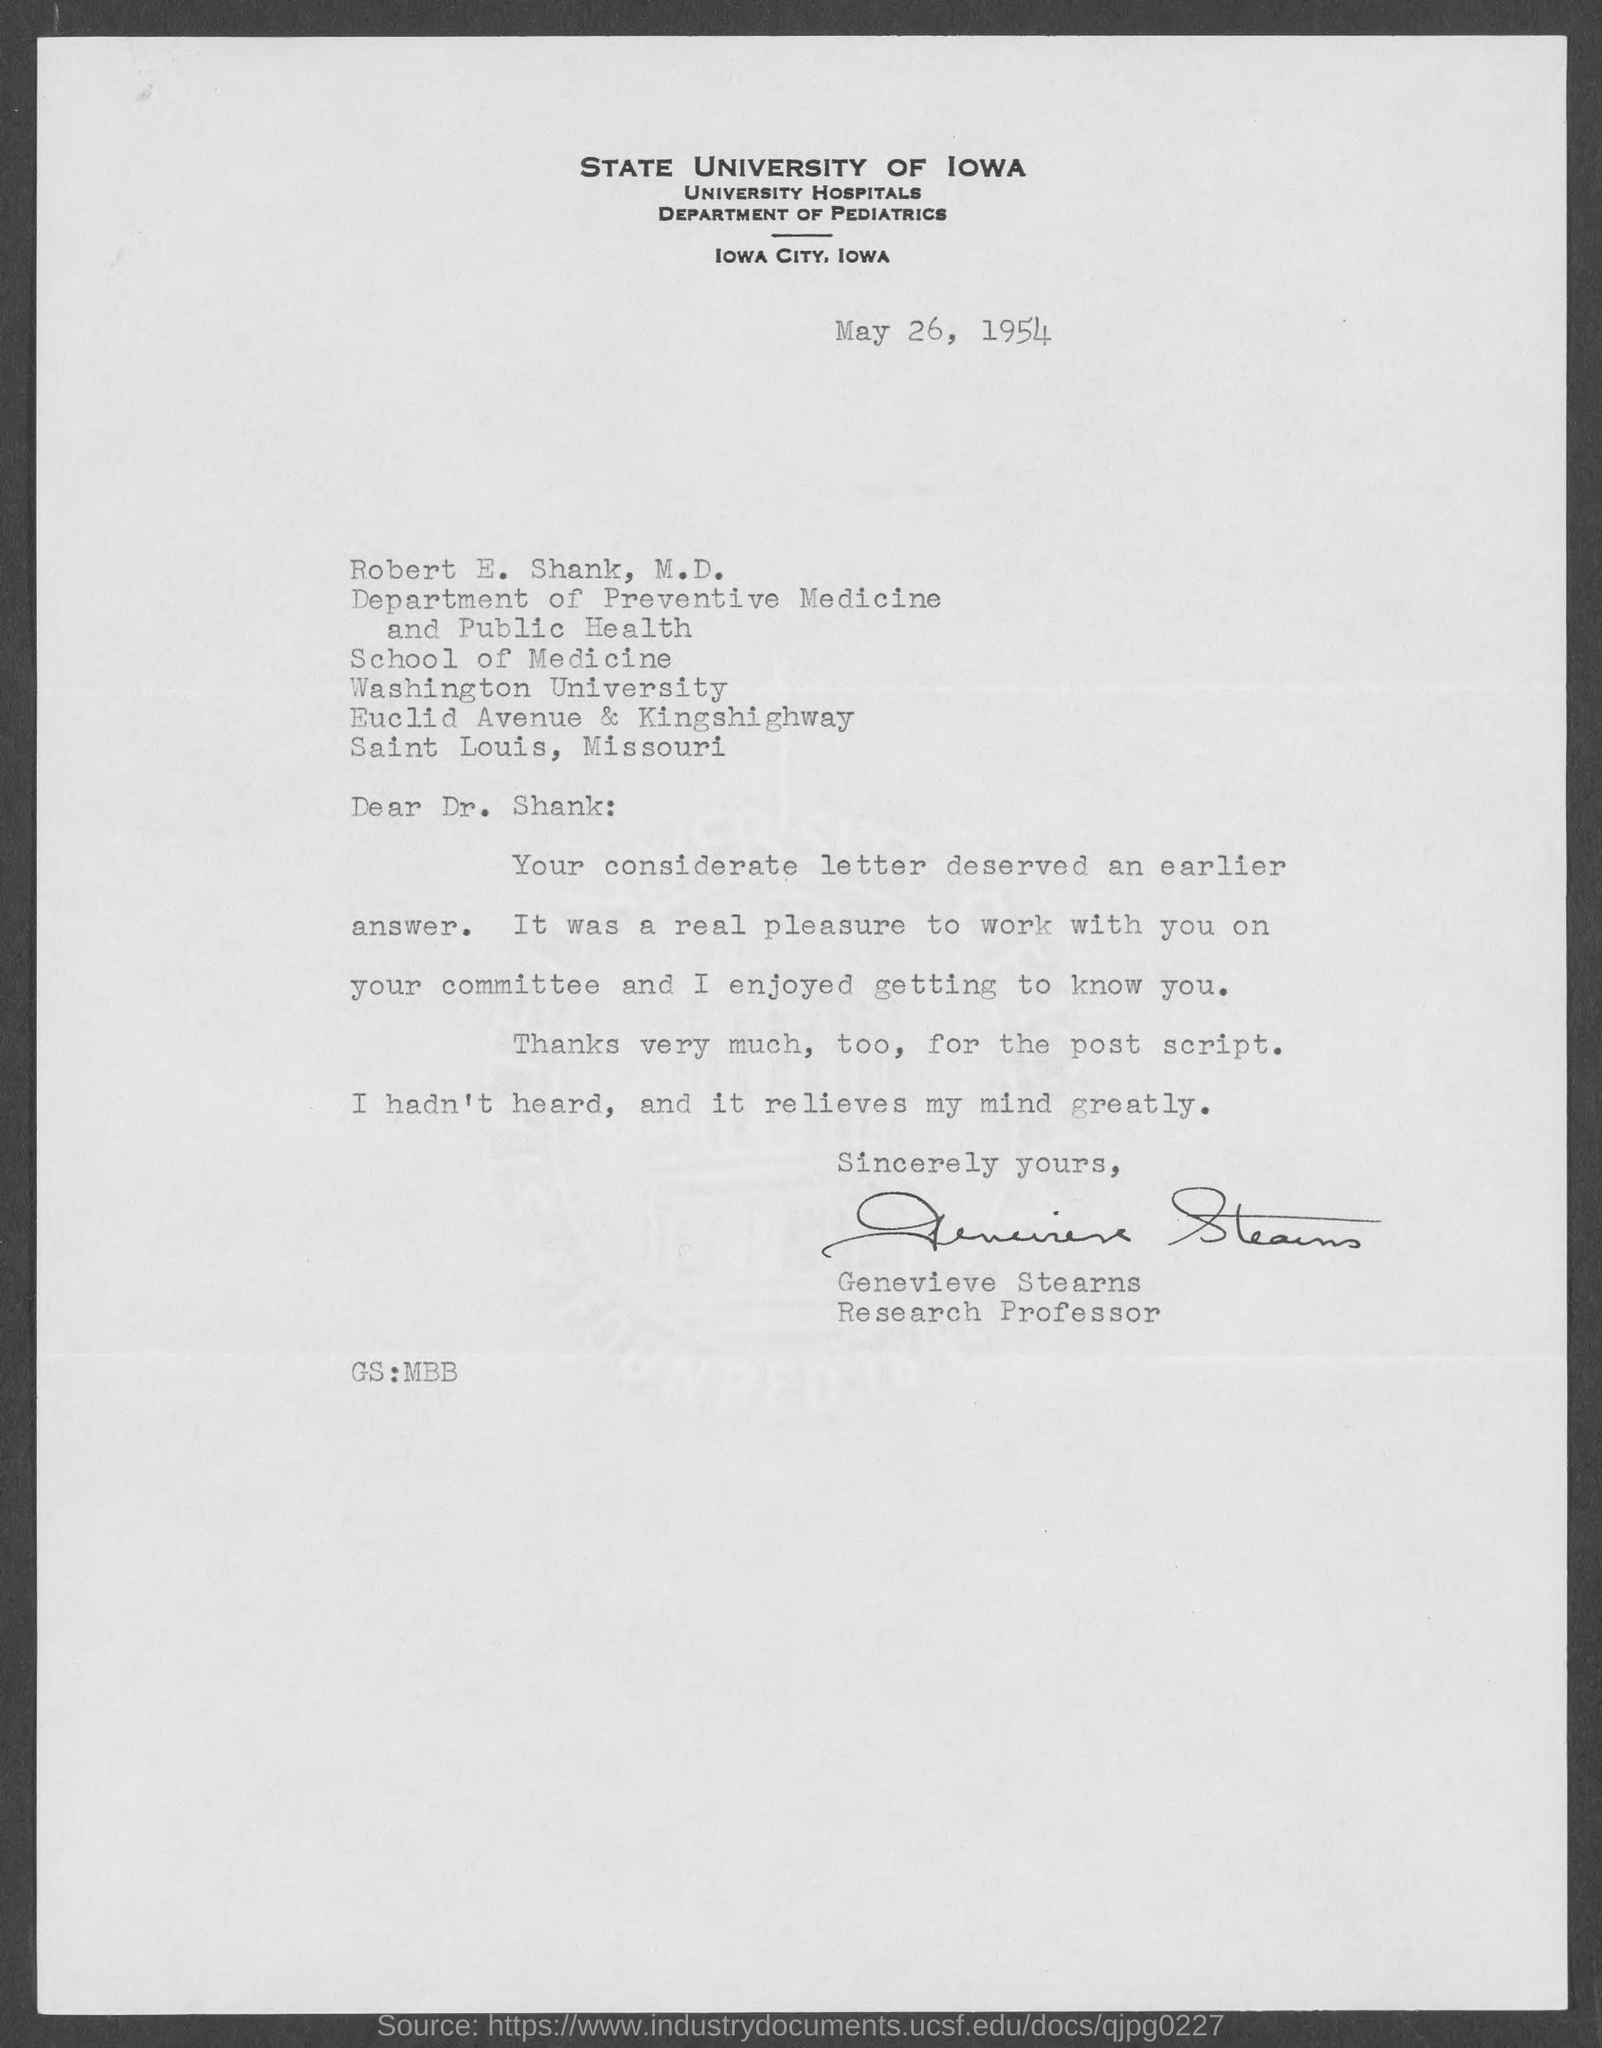When is the memorandum dated on ?
Give a very brief answer. MAY 26, 1954. 